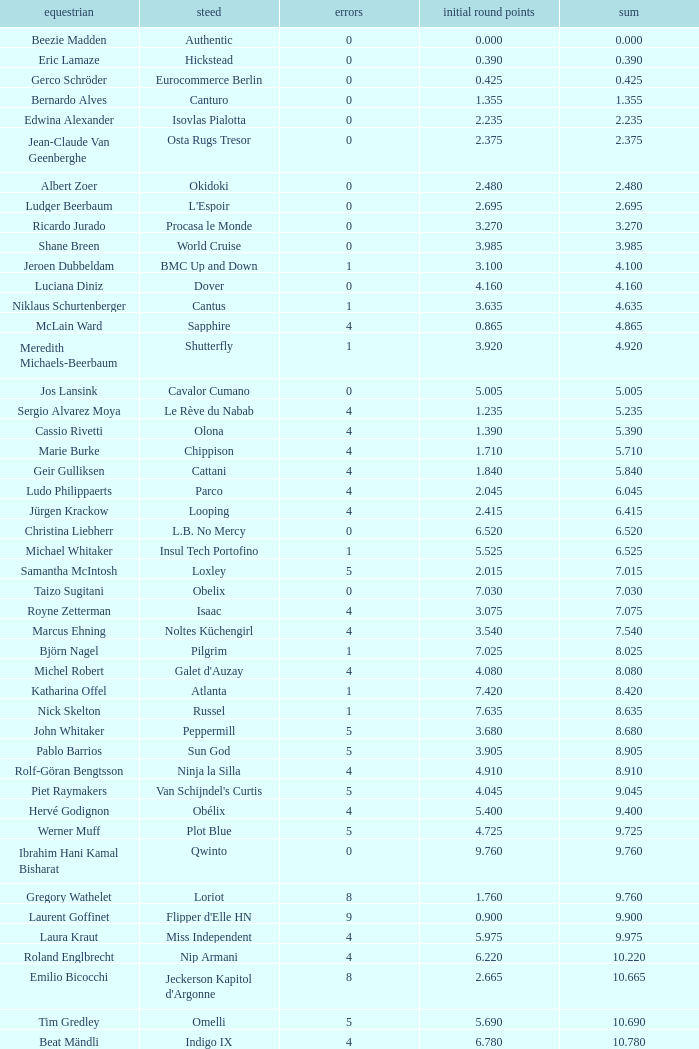Tell me the rider that had round 1 points of 7.465 and total more than 16.615 Manuel Fernandez Saro. 